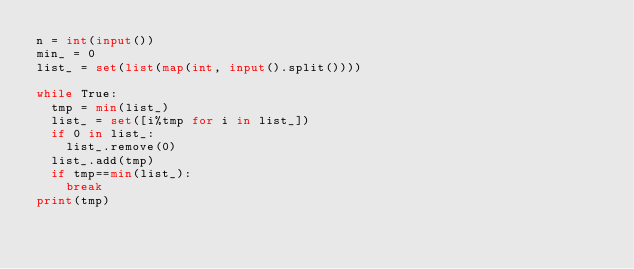<code> <loc_0><loc_0><loc_500><loc_500><_Python_>n = int(input())
min_ = 0
list_ = set(list(map(int, input().split())))

while True:
  tmp = min(list_)
  list_ = set([i%tmp for i in list_])
  if 0 in list_:
    list_.remove(0)
  list_.add(tmp)
  if tmp==min(list_):
    break
print(tmp)</code> 